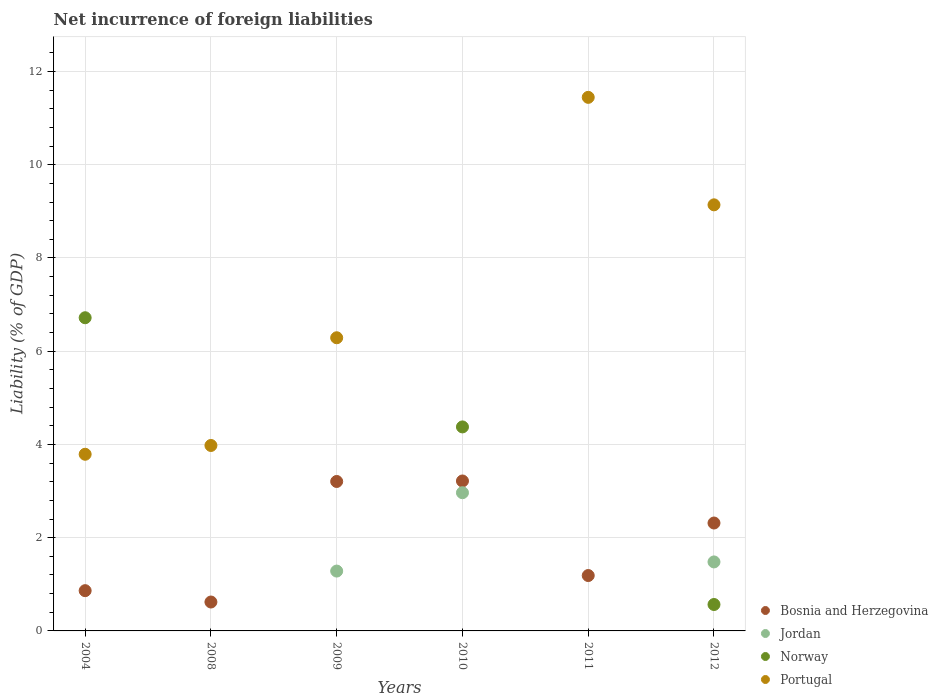Is the number of dotlines equal to the number of legend labels?
Your answer should be compact. No. What is the net incurrence of foreign liabilities in Jordan in 2011?
Make the answer very short. 0. Across all years, what is the maximum net incurrence of foreign liabilities in Jordan?
Your answer should be very brief. 2.96. What is the total net incurrence of foreign liabilities in Portugal in the graph?
Provide a succinct answer. 34.64. What is the difference between the net incurrence of foreign liabilities in Bosnia and Herzegovina in 2004 and that in 2011?
Ensure brevity in your answer.  -0.32. What is the difference between the net incurrence of foreign liabilities in Portugal in 2011 and the net incurrence of foreign liabilities in Norway in 2009?
Offer a terse response. 11.45. What is the average net incurrence of foreign liabilities in Jordan per year?
Ensure brevity in your answer.  0.95. In the year 2011, what is the difference between the net incurrence of foreign liabilities in Portugal and net incurrence of foreign liabilities in Bosnia and Herzegovina?
Your answer should be very brief. 10.26. In how many years, is the net incurrence of foreign liabilities in Jordan greater than 6.8 %?
Your answer should be very brief. 0. What is the ratio of the net incurrence of foreign liabilities in Portugal in 2009 to that in 2012?
Ensure brevity in your answer.  0.69. Is the net incurrence of foreign liabilities in Portugal in 2009 less than that in 2011?
Make the answer very short. Yes. What is the difference between the highest and the second highest net incurrence of foreign liabilities in Portugal?
Give a very brief answer. 2.31. What is the difference between the highest and the lowest net incurrence of foreign liabilities in Bosnia and Herzegovina?
Your answer should be very brief. 2.6. Is it the case that in every year, the sum of the net incurrence of foreign liabilities in Jordan and net incurrence of foreign liabilities in Portugal  is greater than the sum of net incurrence of foreign liabilities in Norway and net incurrence of foreign liabilities in Bosnia and Herzegovina?
Ensure brevity in your answer.  No. Is the net incurrence of foreign liabilities in Norway strictly less than the net incurrence of foreign liabilities in Portugal over the years?
Provide a short and direct response. No. How many dotlines are there?
Provide a succinct answer. 4. How many years are there in the graph?
Your response must be concise. 6. Does the graph contain any zero values?
Keep it short and to the point. Yes. Does the graph contain grids?
Your answer should be very brief. Yes. What is the title of the graph?
Offer a terse response. Net incurrence of foreign liabilities. Does "Korea (Republic)" appear as one of the legend labels in the graph?
Keep it short and to the point. No. What is the label or title of the Y-axis?
Provide a short and direct response. Liability (% of GDP). What is the Liability (% of GDP) of Bosnia and Herzegovina in 2004?
Provide a short and direct response. 0.86. What is the Liability (% of GDP) in Norway in 2004?
Your answer should be very brief. 6.72. What is the Liability (% of GDP) in Portugal in 2004?
Provide a succinct answer. 3.79. What is the Liability (% of GDP) in Bosnia and Herzegovina in 2008?
Provide a short and direct response. 0.62. What is the Liability (% of GDP) of Norway in 2008?
Provide a succinct answer. 0. What is the Liability (% of GDP) of Portugal in 2008?
Offer a very short reply. 3.98. What is the Liability (% of GDP) in Bosnia and Herzegovina in 2009?
Give a very brief answer. 3.21. What is the Liability (% of GDP) of Jordan in 2009?
Make the answer very short. 1.28. What is the Liability (% of GDP) of Portugal in 2009?
Give a very brief answer. 6.29. What is the Liability (% of GDP) of Bosnia and Herzegovina in 2010?
Provide a succinct answer. 3.22. What is the Liability (% of GDP) of Jordan in 2010?
Offer a very short reply. 2.96. What is the Liability (% of GDP) of Norway in 2010?
Your answer should be compact. 4.38. What is the Liability (% of GDP) of Portugal in 2010?
Keep it short and to the point. 0. What is the Liability (% of GDP) in Bosnia and Herzegovina in 2011?
Ensure brevity in your answer.  1.19. What is the Liability (% of GDP) of Portugal in 2011?
Make the answer very short. 11.45. What is the Liability (% of GDP) in Bosnia and Herzegovina in 2012?
Your answer should be very brief. 2.31. What is the Liability (% of GDP) in Jordan in 2012?
Your answer should be compact. 1.48. What is the Liability (% of GDP) of Norway in 2012?
Offer a terse response. 0.57. What is the Liability (% of GDP) of Portugal in 2012?
Offer a very short reply. 9.14. Across all years, what is the maximum Liability (% of GDP) of Bosnia and Herzegovina?
Provide a succinct answer. 3.22. Across all years, what is the maximum Liability (% of GDP) of Jordan?
Your answer should be compact. 2.96. Across all years, what is the maximum Liability (% of GDP) of Norway?
Provide a short and direct response. 6.72. Across all years, what is the maximum Liability (% of GDP) in Portugal?
Provide a succinct answer. 11.45. Across all years, what is the minimum Liability (% of GDP) of Bosnia and Herzegovina?
Ensure brevity in your answer.  0.62. Across all years, what is the minimum Liability (% of GDP) in Jordan?
Provide a short and direct response. 0. Across all years, what is the minimum Liability (% of GDP) of Norway?
Make the answer very short. 0. Across all years, what is the minimum Liability (% of GDP) in Portugal?
Ensure brevity in your answer.  0. What is the total Liability (% of GDP) in Bosnia and Herzegovina in the graph?
Provide a short and direct response. 11.41. What is the total Liability (% of GDP) of Jordan in the graph?
Offer a very short reply. 5.73. What is the total Liability (% of GDP) in Norway in the graph?
Provide a succinct answer. 11.66. What is the total Liability (% of GDP) of Portugal in the graph?
Your answer should be very brief. 34.64. What is the difference between the Liability (% of GDP) of Bosnia and Herzegovina in 2004 and that in 2008?
Keep it short and to the point. 0.24. What is the difference between the Liability (% of GDP) in Portugal in 2004 and that in 2008?
Your response must be concise. -0.19. What is the difference between the Liability (% of GDP) in Bosnia and Herzegovina in 2004 and that in 2009?
Your response must be concise. -2.34. What is the difference between the Liability (% of GDP) in Portugal in 2004 and that in 2009?
Offer a very short reply. -2.5. What is the difference between the Liability (% of GDP) in Bosnia and Herzegovina in 2004 and that in 2010?
Give a very brief answer. -2.35. What is the difference between the Liability (% of GDP) of Norway in 2004 and that in 2010?
Your answer should be compact. 2.34. What is the difference between the Liability (% of GDP) of Bosnia and Herzegovina in 2004 and that in 2011?
Your answer should be compact. -0.32. What is the difference between the Liability (% of GDP) in Portugal in 2004 and that in 2011?
Your response must be concise. -7.66. What is the difference between the Liability (% of GDP) in Bosnia and Herzegovina in 2004 and that in 2012?
Your response must be concise. -1.45. What is the difference between the Liability (% of GDP) of Norway in 2004 and that in 2012?
Give a very brief answer. 6.15. What is the difference between the Liability (% of GDP) of Portugal in 2004 and that in 2012?
Offer a very short reply. -5.35. What is the difference between the Liability (% of GDP) in Bosnia and Herzegovina in 2008 and that in 2009?
Provide a succinct answer. -2.59. What is the difference between the Liability (% of GDP) of Portugal in 2008 and that in 2009?
Your response must be concise. -2.31. What is the difference between the Liability (% of GDP) in Bosnia and Herzegovina in 2008 and that in 2010?
Your answer should be very brief. -2.6. What is the difference between the Liability (% of GDP) in Bosnia and Herzegovina in 2008 and that in 2011?
Offer a very short reply. -0.57. What is the difference between the Liability (% of GDP) in Portugal in 2008 and that in 2011?
Keep it short and to the point. -7.47. What is the difference between the Liability (% of GDP) of Bosnia and Herzegovina in 2008 and that in 2012?
Offer a terse response. -1.69. What is the difference between the Liability (% of GDP) of Portugal in 2008 and that in 2012?
Your answer should be compact. -5.16. What is the difference between the Liability (% of GDP) of Bosnia and Herzegovina in 2009 and that in 2010?
Make the answer very short. -0.01. What is the difference between the Liability (% of GDP) of Jordan in 2009 and that in 2010?
Offer a very short reply. -1.68. What is the difference between the Liability (% of GDP) of Bosnia and Herzegovina in 2009 and that in 2011?
Provide a short and direct response. 2.02. What is the difference between the Liability (% of GDP) in Portugal in 2009 and that in 2011?
Provide a succinct answer. -5.16. What is the difference between the Liability (% of GDP) of Bosnia and Herzegovina in 2009 and that in 2012?
Offer a terse response. 0.89. What is the difference between the Liability (% of GDP) in Jordan in 2009 and that in 2012?
Your answer should be compact. -0.2. What is the difference between the Liability (% of GDP) of Portugal in 2009 and that in 2012?
Your answer should be compact. -2.85. What is the difference between the Liability (% of GDP) in Bosnia and Herzegovina in 2010 and that in 2011?
Your answer should be compact. 2.03. What is the difference between the Liability (% of GDP) of Bosnia and Herzegovina in 2010 and that in 2012?
Your response must be concise. 0.9. What is the difference between the Liability (% of GDP) of Jordan in 2010 and that in 2012?
Make the answer very short. 1.48. What is the difference between the Liability (% of GDP) of Norway in 2010 and that in 2012?
Your answer should be compact. 3.81. What is the difference between the Liability (% of GDP) in Bosnia and Herzegovina in 2011 and that in 2012?
Offer a terse response. -1.13. What is the difference between the Liability (% of GDP) in Portugal in 2011 and that in 2012?
Keep it short and to the point. 2.31. What is the difference between the Liability (% of GDP) in Bosnia and Herzegovina in 2004 and the Liability (% of GDP) in Portugal in 2008?
Your answer should be compact. -3.11. What is the difference between the Liability (% of GDP) of Norway in 2004 and the Liability (% of GDP) of Portugal in 2008?
Offer a terse response. 2.74. What is the difference between the Liability (% of GDP) in Bosnia and Herzegovina in 2004 and the Liability (% of GDP) in Jordan in 2009?
Offer a terse response. -0.42. What is the difference between the Liability (% of GDP) of Bosnia and Herzegovina in 2004 and the Liability (% of GDP) of Portugal in 2009?
Keep it short and to the point. -5.42. What is the difference between the Liability (% of GDP) of Norway in 2004 and the Liability (% of GDP) of Portugal in 2009?
Provide a succinct answer. 0.43. What is the difference between the Liability (% of GDP) of Bosnia and Herzegovina in 2004 and the Liability (% of GDP) of Jordan in 2010?
Provide a short and direct response. -2.1. What is the difference between the Liability (% of GDP) in Bosnia and Herzegovina in 2004 and the Liability (% of GDP) in Norway in 2010?
Offer a terse response. -3.51. What is the difference between the Liability (% of GDP) of Bosnia and Herzegovina in 2004 and the Liability (% of GDP) of Portugal in 2011?
Your answer should be very brief. -10.58. What is the difference between the Liability (% of GDP) of Norway in 2004 and the Liability (% of GDP) of Portugal in 2011?
Provide a short and direct response. -4.73. What is the difference between the Liability (% of GDP) of Bosnia and Herzegovina in 2004 and the Liability (% of GDP) of Jordan in 2012?
Provide a succinct answer. -0.62. What is the difference between the Liability (% of GDP) of Bosnia and Herzegovina in 2004 and the Liability (% of GDP) of Norway in 2012?
Your answer should be very brief. 0.3. What is the difference between the Liability (% of GDP) in Bosnia and Herzegovina in 2004 and the Liability (% of GDP) in Portugal in 2012?
Offer a very short reply. -8.28. What is the difference between the Liability (% of GDP) in Norway in 2004 and the Liability (% of GDP) in Portugal in 2012?
Offer a terse response. -2.42. What is the difference between the Liability (% of GDP) in Bosnia and Herzegovina in 2008 and the Liability (% of GDP) in Jordan in 2009?
Your answer should be very brief. -0.66. What is the difference between the Liability (% of GDP) of Bosnia and Herzegovina in 2008 and the Liability (% of GDP) of Portugal in 2009?
Your response must be concise. -5.67. What is the difference between the Liability (% of GDP) of Bosnia and Herzegovina in 2008 and the Liability (% of GDP) of Jordan in 2010?
Give a very brief answer. -2.34. What is the difference between the Liability (% of GDP) of Bosnia and Herzegovina in 2008 and the Liability (% of GDP) of Norway in 2010?
Provide a short and direct response. -3.76. What is the difference between the Liability (% of GDP) in Bosnia and Herzegovina in 2008 and the Liability (% of GDP) in Portugal in 2011?
Provide a succinct answer. -10.83. What is the difference between the Liability (% of GDP) in Bosnia and Herzegovina in 2008 and the Liability (% of GDP) in Jordan in 2012?
Make the answer very short. -0.86. What is the difference between the Liability (% of GDP) of Bosnia and Herzegovina in 2008 and the Liability (% of GDP) of Norway in 2012?
Offer a very short reply. 0.05. What is the difference between the Liability (% of GDP) of Bosnia and Herzegovina in 2008 and the Liability (% of GDP) of Portugal in 2012?
Provide a short and direct response. -8.52. What is the difference between the Liability (% of GDP) in Bosnia and Herzegovina in 2009 and the Liability (% of GDP) in Jordan in 2010?
Your response must be concise. 0.24. What is the difference between the Liability (% of GDP) of Bosnia and Herzegovina in 2009 and the Liability (% of GDP) of Norway in 2010?
Your response must be concise. -1.17. What is the difference between the Liability (% of GDP) of Jordan in 2009 and the Liability (% of GDP) of Norway in 2010?
Your response must be concise. -3.09. What is the difference between the Liability (% of GDP) in Bosnia and Herzegovina in 2009 and the Liability (% of GDP) in Portugal in 2011?
Give a very brief answer. -8.24. What is the difference between the Liability (% of GDP) of Jordan in 2009 and the Liability (% of GDP) of Portugal in 2011?
Your answer should be very brief. -10.16. What is the difference between the Liability (% of GDP) of Bosnia and Herzegovina in 2009 and the Liability (% of GDP) of Jordan in 2012?
Your answer should be compact. 1.73. What is the difference between the Liability (% of GDP) of Bosnia and Herzegovina in 2009 and the Liability (% of GDP) of Norway in 2012?
Provide a short and direct response. 2.64. What is the difference between the Liability (% of GDP) of Bosnia and Herzegovina in 2009 and the Liability (% of GDP) of Portugal in 2012?
Keep it short and to the point. -5.93. What is the difference between the Liability (% of GDP) of Jordan in 2009 and the Liability (% of GDP) of Norway in 2012?
Provide a succinct answer. 0.72. What is the difference between the Liability (% of GDP) in Jordan in 2009 and the Liability (% of GDP) in Portugal in 2012?
Provide a succinct answer. -7.86. What is the difference between the Liability (% of GDP) of Bosnia and Herzegovina in 2010 and the Liability (% of GDP) of Portugal in 2011?
Ensure brevity in your answer.  -8.23. What is the difference between the Liability (% of GDP) in Jordan in 2010 and the Liability (% of GDP) in Portugal in 2011?
Your response must be concise. -8.48. What is the difference between the Liability (% of GDP) in Norway in 2010 and the Liability (% of GDP) in Portugal in 2011?
Provide a succinct answer. -7.07. What is the difference between the Liability (% of GDP) in Bosnia and Herzegovina in 2010 and the Liability (% of GDP) in Jordan in 2012?
Provide a succinct answer. 1.74. What is the difference between the Liability (% of GDP) of Bosnia and Herzegovina in 2010 and the Liability (% of GDP) of Norway in 2012?
Ensure brevity in your answer.  2.65. What is the difference between the Liability (% of GDP) of Bosnia and Herzegovina in 2010 and the Liability (% of GDP) of Portugal in 2012?
Keep it short and to the point. -5.92. What is the difference between the Liability (% of GDP) of Jordan in 2010 and the Liability (% of GDP) of Norway in 2012?
Your response must be concise. 2.4. What is the difference between the Liability (% of GDP) of Jordan in 2010 and the Liability (% of GDP) of Portugal in 2012?
Keep it short and to the point. -6.18. What is the difference between the Liability (% of GDP) in Norway in 2010 and the Liability (% of GDP) in Portugal in 2012?
Your answer should be very brief. -4.76. What is the difference between the Liability (% of GDP) of Bosnia and Herzegovina in 2011 and the Liability (% of GDP) of Jordan in 2012?
Your response must be concise. -0.29. What is the difference between the Liability (% of GDP) in Bosnia and Herzegovina in 2011 and the Liability (% of GDP) in Norway in 2012?
Your response must be concise. 0.62. What is the difference between the Liability (% of GDP) of Bosnia and Herzegovina in 2011 and the Liability (% of GDP) of Portugal in 2012?
Your response must be concise. -7.95. What is the average Liability (% of GDP) in Bosnia and Herzegovina per year?
Make the answer very short. 1.9. What is the average Liability (% of GDP) of Jordan per year?
Offer a terse response. 0.95. What is the average Liability (% of GDP) in Norway per year?
Provide a short and direct response. 1.94. What is the average Liability (% of GDP) of Portugal per year?
Offer a terse response. 5.77. In the year 2004, what is the difference between the Liability (% of GDP) of Bosnia and Herzegovina and Liability (% of GDP) of Norway?
Ensure brevity in your answer.  -5.85. In the year 2004, what is the difference between the Liability (% of GDP) of Bosnia and Herzegovina and Liability (% of GDP) of Portugal?
Your answer should be compact. -2.93. In the year 2004, what is the difference between the Liability (% of GDP) of Norway and Liability (% of GDP) of Portugal?
Your response must be concise. 2.93. In the year 2008, what is the difference between the Liability (% of GDP) in Bosnia and Herzegovina and Liability (% of GDP) in Portugal?
Offer a very short reply. -3.36. In the year 2009, what is the difference between the Liability (% of GDP) of Bosnia and Herzegovina and Liability (% of GDP) of Jordan?
Offer a terse response. 1.92. In the year 2009, what is the difference between the Liability (% of GDP) of Bosnia and Herzegovina and Liability (% of GDP) of Portugal?
Provide a short and direct response. -3.08. In the year 2009, what is the difference between the Liability (% of GDP) in Jordan and Liability (% of GDP) in Portugal?
Provide a succinct answer. -5. In the year 2010, what is the difference between the Liability (% of GDP) of Bosnia and Herzegovina and Liability (% of GDP) of Jordan?
Provide a short and direct response. 0.25. In the year 2010, what is the difference between the Liability (% of GDP) of Bosnia and Herzegovina and Liability (% of GDP) of Norway?
Offer a very short reply. -1.16. In the year 2010, what is the difference between the Liability (% of GDP) in Jordan and Liability (% of GDP) in Norway?
Your answer should be compact. -1.41. In the year 2011, what is the difference between the Liability (% of GDP) in Bosnia and Herzegovina and Liability (% of GDP) in Portugal?
Your response must be concise. -10.26. In the year 2012, what is the difference between the Liability (% of GDP) of Bosnia and Herzegovina and Liability (% of GDP) of Jordan?
Your answer should be very brief. 0.83. In the year 2012, what is the difference between the Liability (% of GDP) of Bosnia and Herzegovina and Liability (% of GDP) of Norway?
Make the answer very short. 1.75. In the year 2012, what is the difference between the Liability (% of GDP) of Bosnia and Herzegovina and Liability (% of GDP) of Portugal?
Your answer should be very brief. -6.83. In the year 2012, what is the difference between the Liability (% of GDP) in Jordan and Liability (% of GDP) in Norway?
Your response must be concise. 0.91. In the year 2012, what is the difference between the Liability (% of GDP) of Jordan and Liability (% of GDP) of Portugal?
Offer a terse response. -7.66. In the year 2012, what is the difference between the Liability (% of GDP) in Norway and Liability (% of GDP) in Portugal?
Provide a short and direct response. -8.57. What is the ratio of the Liability (% of GDP) in Bosnia and Herzegovina in 2004 to that in 2008?
Ensure brevity in your answer.  1.39. What is the ratio of the Liability (% of GDP) in Portugal in 2004 to that in 2008?
Offer a very short reply. 0.95. What is the ratio of the Liability (% of GDP) in Bosnia and Herzegovina in 2004 to that in 2009?
Your response must be concise. 0.27. What is the ratio of the Liability (% of GDP) in Portugal in 2004 to that in 2009?
Provide a succinct answer. 0.6. What is the ratio of the Liability (% of GDP) in Bosnia and Herzegovina in 2004 to that in 2010?
Ensure brevity in your answer.  0.27. What is the ratio of the Liability (% of GDP) in Norway in 2004 to that in 2010?
Offer a terse response. 1.54. What is the ratio of the Liability (% of GDP) in Bosnia and Herzegovina in 2004 to that in 2011?
Provide a short and direct response. 0.73. What is the ratio of the Liability (% of GDP) in Portugal in 2004 to that in 2011?
Offer a very short reply. 0.33. What is the ratio of the Liability (% of GDP) in Bosnia and Herzegovina in 2004 to that in 2012?
Ensure brevity in your answer.  0.37. What is the ratio of the Liability (% of GDP) in Norway in 2004 to that in 2012?
Offer a very short reply. 11.86. What is the ratio of the Liability (% of GDP) of Portugal in 2004 to that in 2012?
Keep it short and to the point. 0.41. What is the ratio of the Liability (% of GDP) in Bosnia and Herzegovina in 2008 to that in 2009?
Provide a short and direct response. 0.19. What is the ratio of the Liability (% of GDP) in Portugal in 2008 to that in 2009?
Give a very brief answer. 0.63. What is the ratio of the Liability (% of GDP) of Bosnia and Herzegovina in 2008 to that in 2010?
Make the answer very short. 0.19. What is the ratio of the Liability (% of GDP) of Bosnia and Herzegovina in 2008 to that in 2011?
Give a very brief answer. 0.52. What is the ratio of the Liability (% of GDP) in Portugal in 2008 to that in 2011?
Give a very brief answer. 0.35. What is the ratio of the Liability (% of GDP) of Bosnia and Herzegovina in 2008 to that in 2012?
Provide a short and direct response. 0.27. What is the ratio of the Liability (% of GDP) of Portugal in 2008 to that in 2012?
Offer a terse response. 0.44. What is the ratio of the Liability (% of GDP) of Jordan in 2009 to that in 2010?
Your response must be concise. 0.43. What is the ratio of the Liability (% of GDP) of Bosnia and Herzegovina in 2009 to that in 2011?
Provide a short and direct response. 2.7. What is the ratio of the Liability (% of GDP) of Portugal in 2009 to that in 2011?
Provide a short and direct response. 0.55. What is the ratio of the Liability (% of GDP) of Bosnia and Herzegovina in 2009 to that in 2012?
Your answer should be very brief. 1.39. What is the ratio of the Liability (% of GDP) of Jordan in 2009 to that in 2012?
Ensure brevity in your answer.  0.87. What is the ratio of the Liability (% of GDP) of Portugal in 2009 to that in 2012?
Offer a very short reply. 0.69. What is the ratio of the Liability (% of GDP) of Bosnia and Herzegovina in 2010 to that in 2011?
Make the answer very short. 2.71. What is the ratio of the Liability (% of GDP) in Bosnia and Herzegovina in 2010 to that in 2012?
Offer a terse response. 1.39. What is the ratio of the Liability (% of GDP) in Jordan in 2010 to that in 2012?
Make the answer very short. 2. What is the ratio of the Liability (% of GDP) of Norway in 2010 to that in 2012?
Your answer should be compact. 7.72. What is the ratio of the Liability (% of GDP) in Bosnia and Herzegovina in 2011 to that in 2012?
Offer a very short reply. 0.51. What is the ratio of the Liability (% of GDP) in Portugal in 2011 to that in 2012?
Make the answer very short. 1.25. What is the difference between the highest and the second highest Liability (% of GDP) of Bosnia and Herzegovina?
Offer a terse response. 0.01. What is the difference between the highest and the second highest Liability (% of GDP) in Jordan?
Make the answer very short. 1.48. What is the difference between the highest and the second highest Liability (% of GDP) in Norway?
Make the answer very short. 2.34. What is the difference between the highest and the second highest Liability (% of GDP) of Portugal?
Keep it short and to the point. 2.31. What is the difference between the highest and the lowest Liability (% of GDP) in Bosnia and Herzegovina?
Keep it short and to the point. 2.6. What is the difference between the highest and the lowest Liability (% of GDP) of Jordan?
Your answer should be very brief. 2.96. What is the difference between the highest and the lowest Liability (% of GDP) in Norway?
Make the answer very short. 6.72. What is the difference between the highest and the lowest Liability (% of GDP) of Portugal?
Make the answer very short. 11.45. 